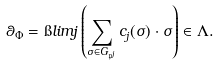Convert formula to latex. <formula><loc_0><loc_0><loc_500><loc_500>\theta _ { \Phi } = \i l i m j \left ( \sum _ { \sigma \in G _ { \mathfrak { p } ^ { j } } } c _ { j } ( \sigma ) \cdot \sigma \right ) \in \Lambda .</formula> 